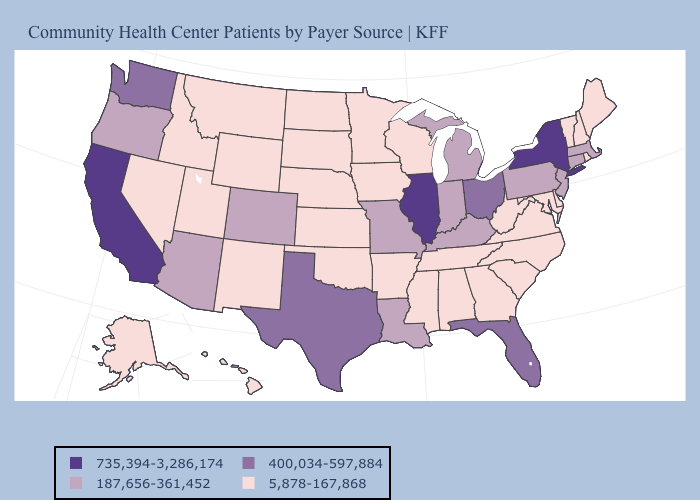Does New Mexico have the highest value in the USA?
Answer briefly. No. Does Iowa have the lowest value in the USA?
Quick response, please. Yes. What is the value of Montana?
Quick response, please. 5,878-167,868. Does Alabama have the lowest value in the USA?
Write a very short answer. Yes. Among the states that border Nebraska , which have the highest value?
Answer briefly. Colorado, Missouri. Is the legend a continuous bar?
Answer briefly. No. What is the value of North Carolina?
Concise answer only. 5,878-167,868. Among the states that border Missouri , which have the lowest value?
Keep it brief. Arkansas, Iowa, Kansas, Nebraska, Oklahoma, Tennessee. Which states have the lowest value in the USA?
Be succinct. Alabama, Alaska, Arkansas, Delaware, Georgia, Hawaii, Idaho, Iowa, Kansas, Maine, Maryland, Minnesota, Mississippi, Montana, Nebraska, Nevada, New Hampshire, New Mexico, North Carolina, North Dakota, Oklahoma, Rhode Island, South Carolina, South Dakota, Tennessee, Utah, Vermont, Virginia, West Virginia, Wisconsin, Wyoming. How many symbols are there in the legend?
Answer briefly. 4. What is the highest value in the West ?
Give a very brief answer. 735,394-3,286,174. What is the highest value in states that border Connecticut?
Give a very brief answer. 735,394-3,286,174. Among the states that border Kansas , does Nebraska have the highest value?
Write a very short answer. No. Among the states that border Nevada , does Utah have the highest value?
Be succinct. No. Does Wisconsin have the highest value in the MidWest?
Give a very brief answer. No. 